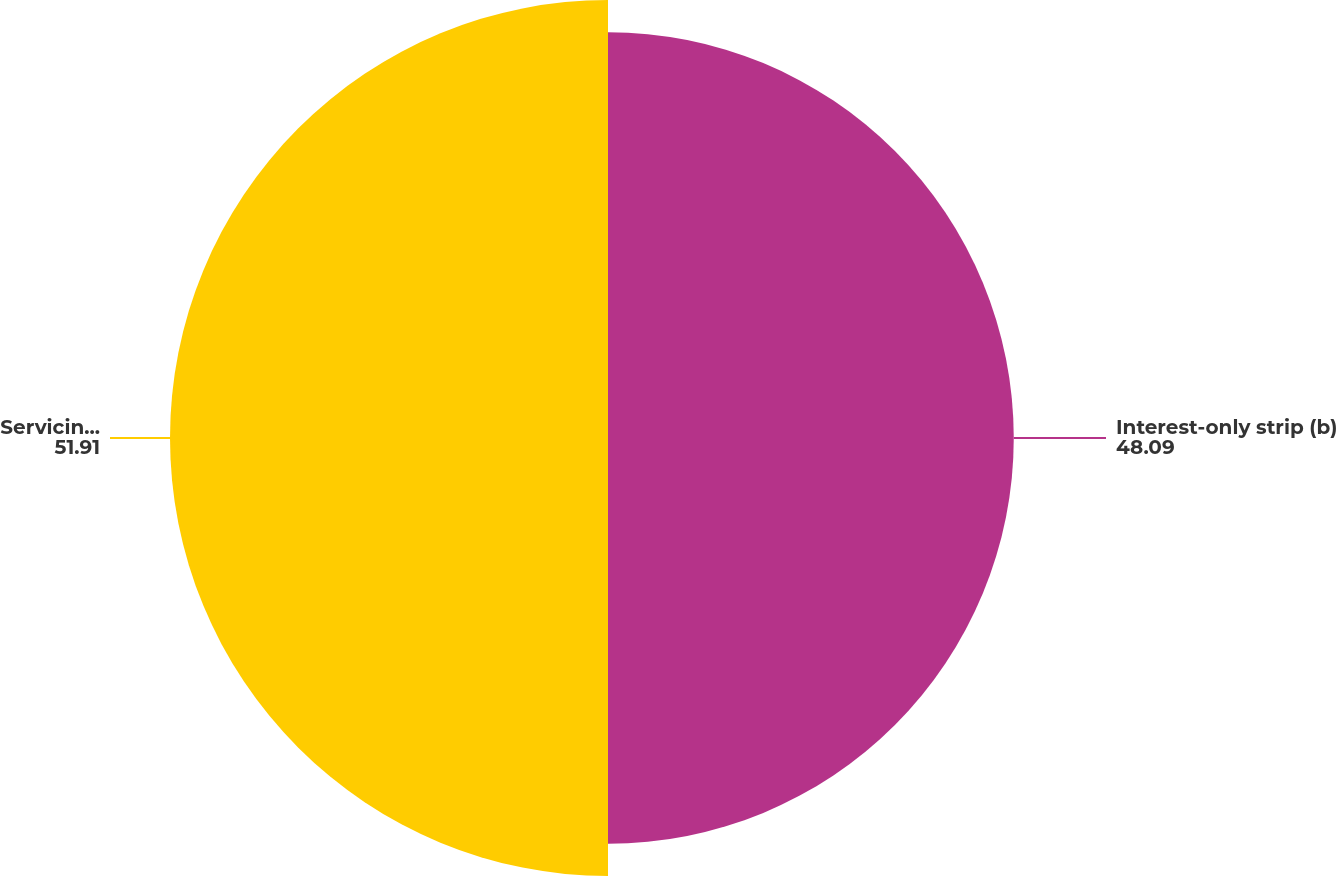Convert chart to OTSL. <chart><loc_0><loc_0><loc_500><loc_500><pie_chart><fcel>Interest-only strip (b)<fcel>Servicing asset (b)<nl><fcel>48.09%<fcel>51.91%<nl></chart> 